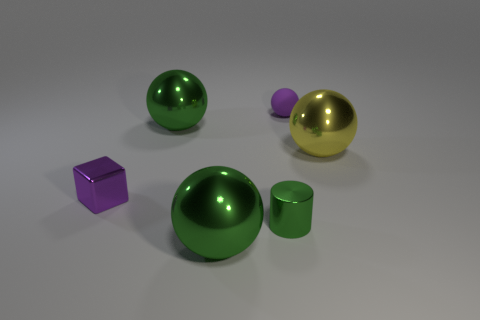Is there anything else that has the same material as the purple ball?
Your answer should be very brief. No. The small green metal thing that is on the right side of the cube has what shape?
Make the answer very short. Cylinder. There is a rubber object that is behind the large green metallic object that is in front of the large metal thing that is to the right of the small sphere; what size is it?
Your answer should be compact. Small. Is the matte object the same shape as the yellow thing?
Provide a short and direct response. Yes. What is the size of the shiny thing that is both behind the cylinder and in front of the yellow ball?
Provide a succinct answer. Small. What is the material of the tiny object that is the same shape as the large yellow object?
Offer a very short reply. Rubber. There is a object to the left of the large green thing that is behind the small green thing; what is it made of?
Offer a very short reply. Metal. There is a large yellow shiny thing; is its shape the same as the tiny purple object in front of the large yellow sphere?
Your response must be concise. No. What number of shiny things are either yellow balls or green balls?
Offer a very short reply. 3. There is a large shiny object that is on the right side of the tiny green shiny cylinder to the left of the large metal object that is to the right of the small purple matte sphere; what is its color?
Provide a short and direct response. Yellow. 